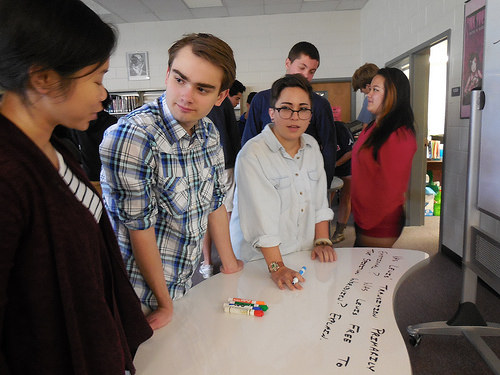<image>
Can you confirm if the women is to the left of the boy? Yes. From this viewpoint, the women is positioned to the left side relative to the boy. Is there a woman in front of the man? Yes. The woman is positioned in front of the man, appearing closer to the camera viewpoint. 